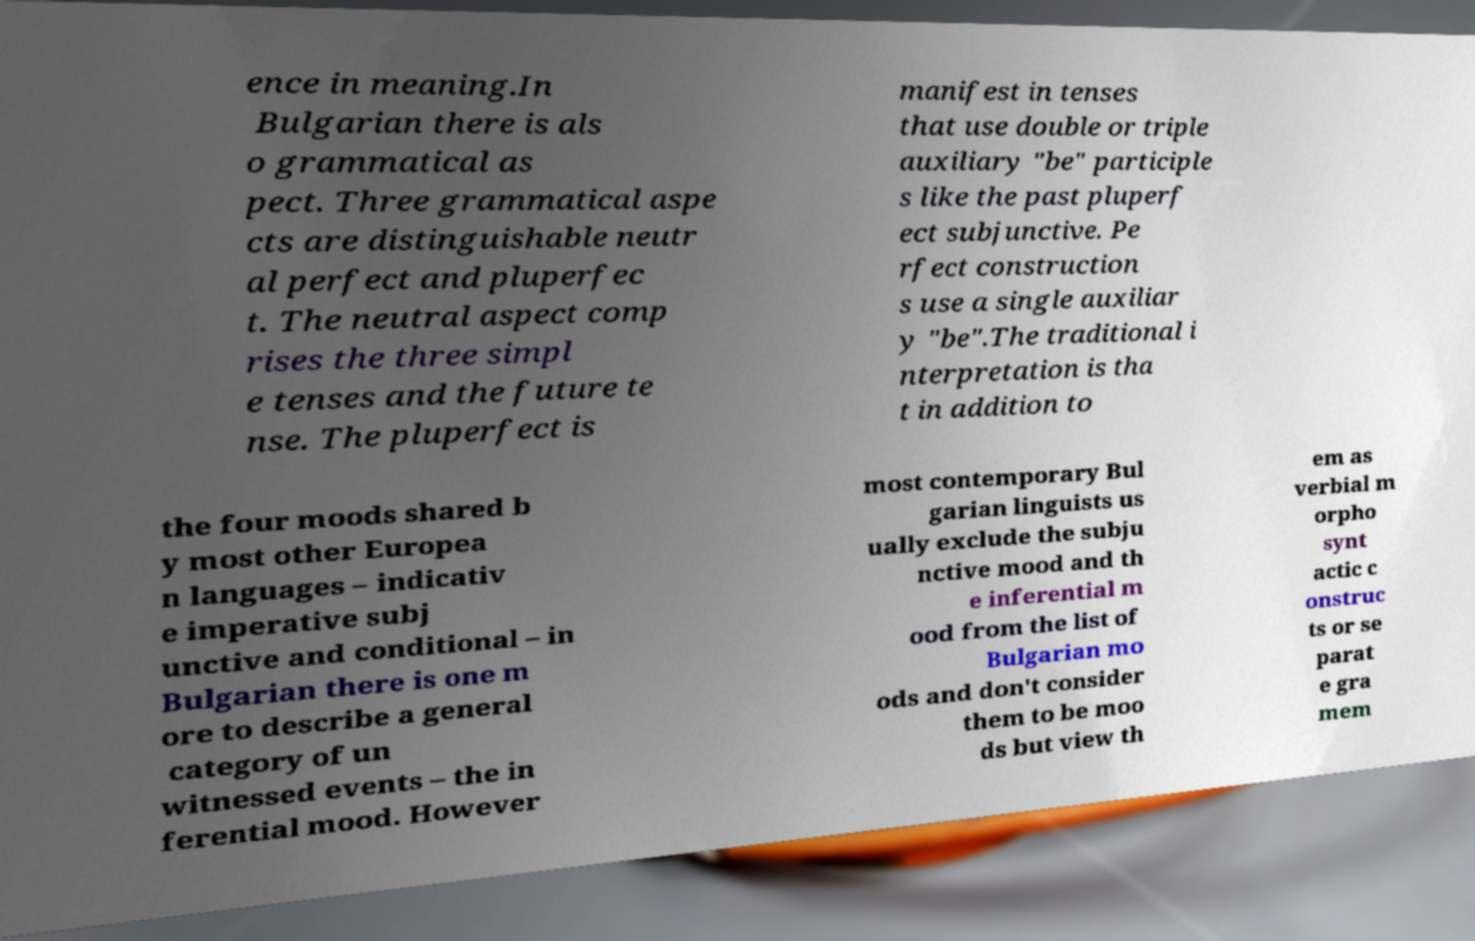Could you extract and type out the text from this image? ence in meaning.In Bulgarian there is als o grammatical as pect. Three grammatical aspe cts are distinguishable neutr al perfect and pluperfec t. The neutral aspect comp rises the three simpl e tenses and the future te nse. The pluperfect is manifest in tenses that use double or triple auxiliary "be" participle s like the past pluperf ect subjunctive. Pe rfect construction s use a single auxiliar y "be".The traditional i nterpretation is tha t in addition to the four moods shared b y most other Europea n languages – indicativ e imperative subj unctive and conditional – in Bulgarian there is one m ore to describe a general category of un witnessed events – the in ferential mood. However most contemporary Bul garian linguists us ually exclude the subju nctive mood and th e inferential m ood from the list of Bulgarian mo ods and don't consider them to be moo ds but view th em as verbial m orpho synt actic c onstruc ts or se parat e gra mem 